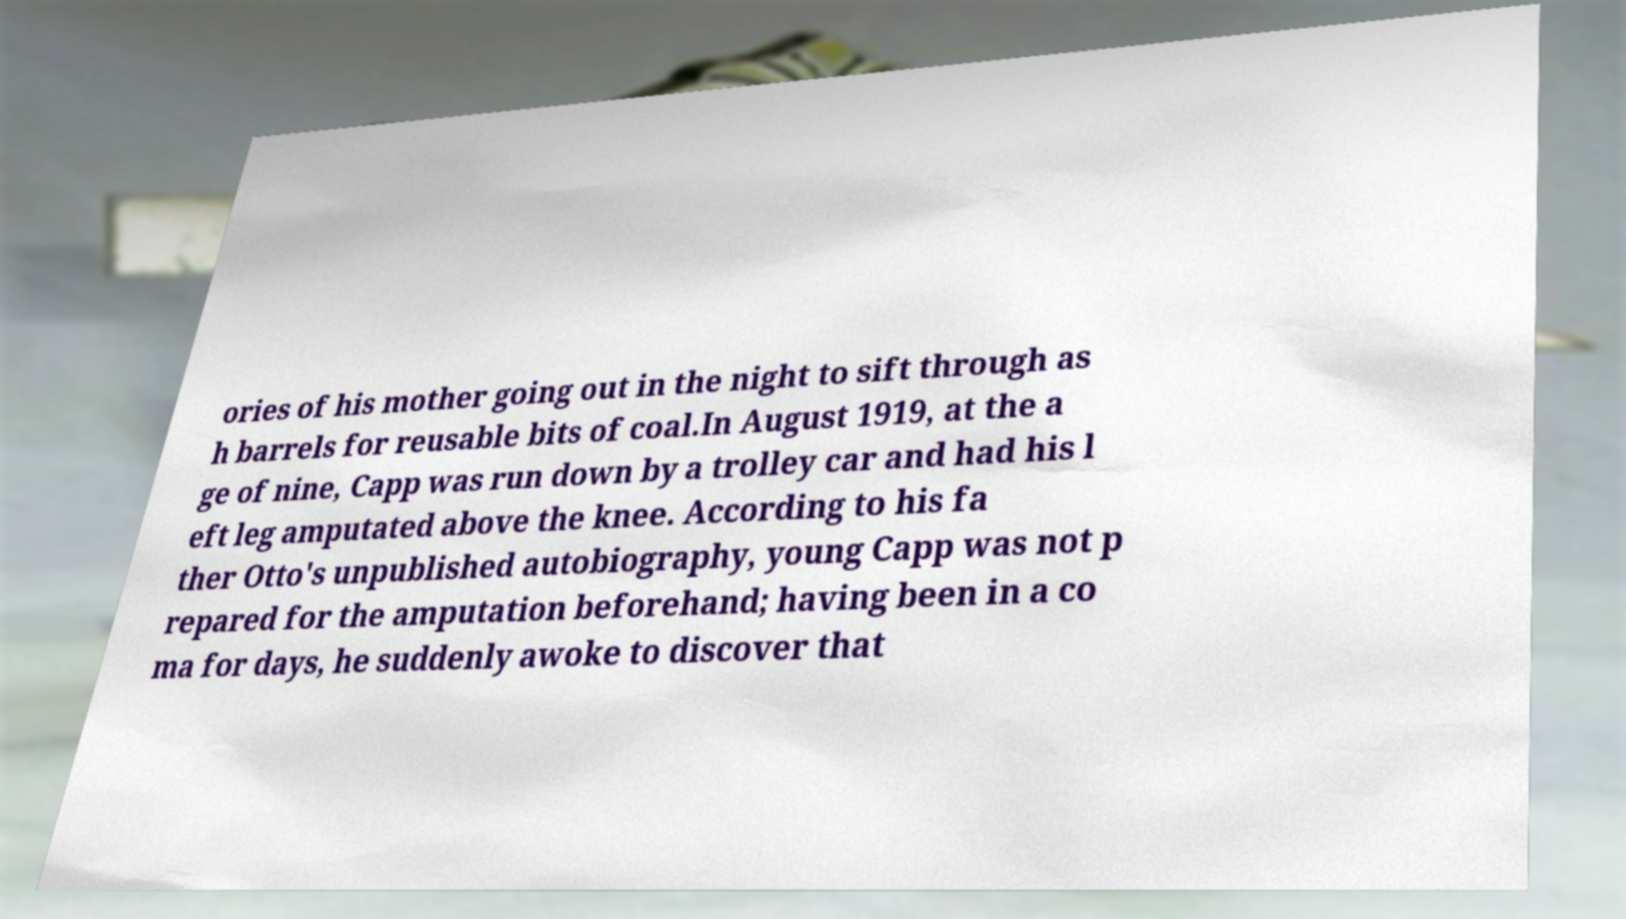There's text embedded in this image that I need extracted. Can you transcribe it verbatim? ories of his mother going out in the night to sift through as h barrels for reusable bits of coal.In August 1919, at the a ge of nine, Capp was run down by a trolley car and had his l eft leg amputated above the knee. According to his fa ther Otto's unpublished autobiography, young Capp was not p repared for the amputation beforehand; having been in a co ma for days, he suddenly awoke to discover that 